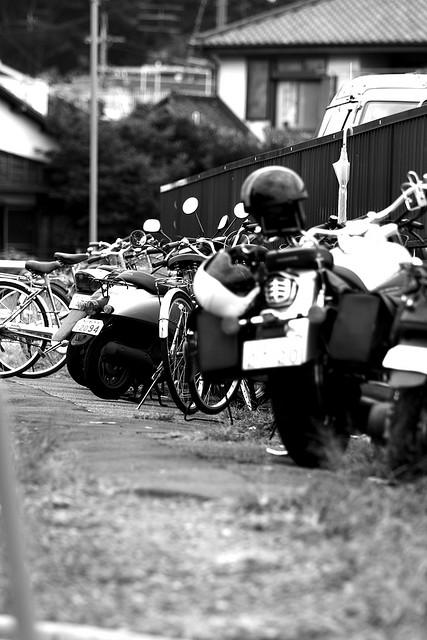How many helmets do you see?
Quick response, please. 2. Are motorcycles visible?
Give a very brief answer. Yes. Is this in color?
Quick response, please. No. 